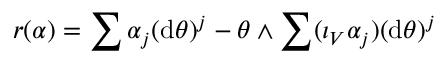Convert formula to latex. <formula><loc_0><loc_0><loc_500><loc_500>r ( \alpha ) = \sum \alpha _ { j } ( d \theta ) ^ { j } - \theta \wedge \sum ( \iota _ { V } \alpha _ { j } ) ( d \theta ) ^ { j }</formula> 